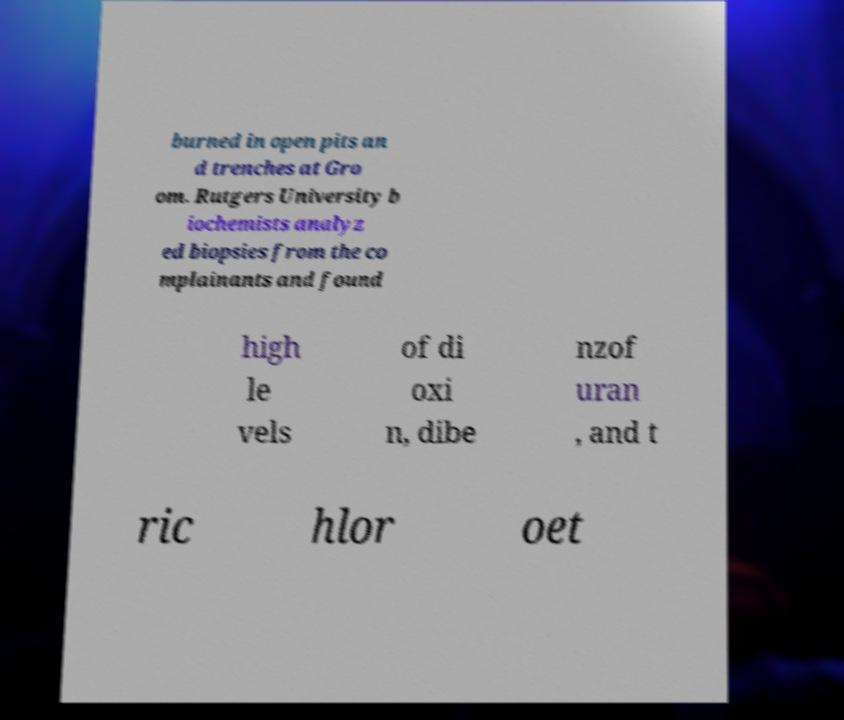I need the written content from this picture converted into text. Can you do that? burned in open pits an d trenches at Gro om. Rutgers University b iochemists analyz ed biopsies from the co mplainants and found high le vels of di oxi n, dibe nzof uran , and t ric hlor oet 